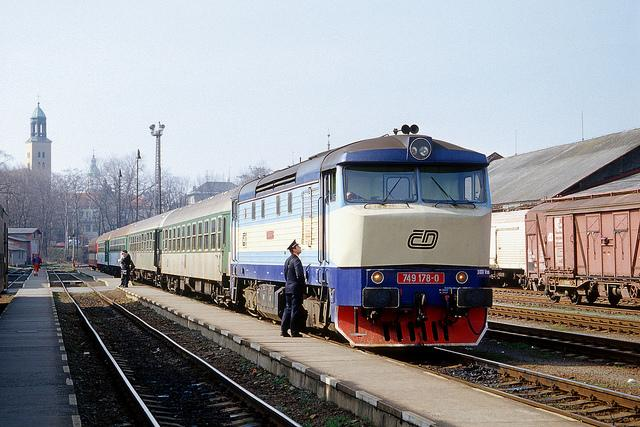What does this vehicle travel on?

Choices:
A) water
B) rails
C) air currents
D) roadways rails 